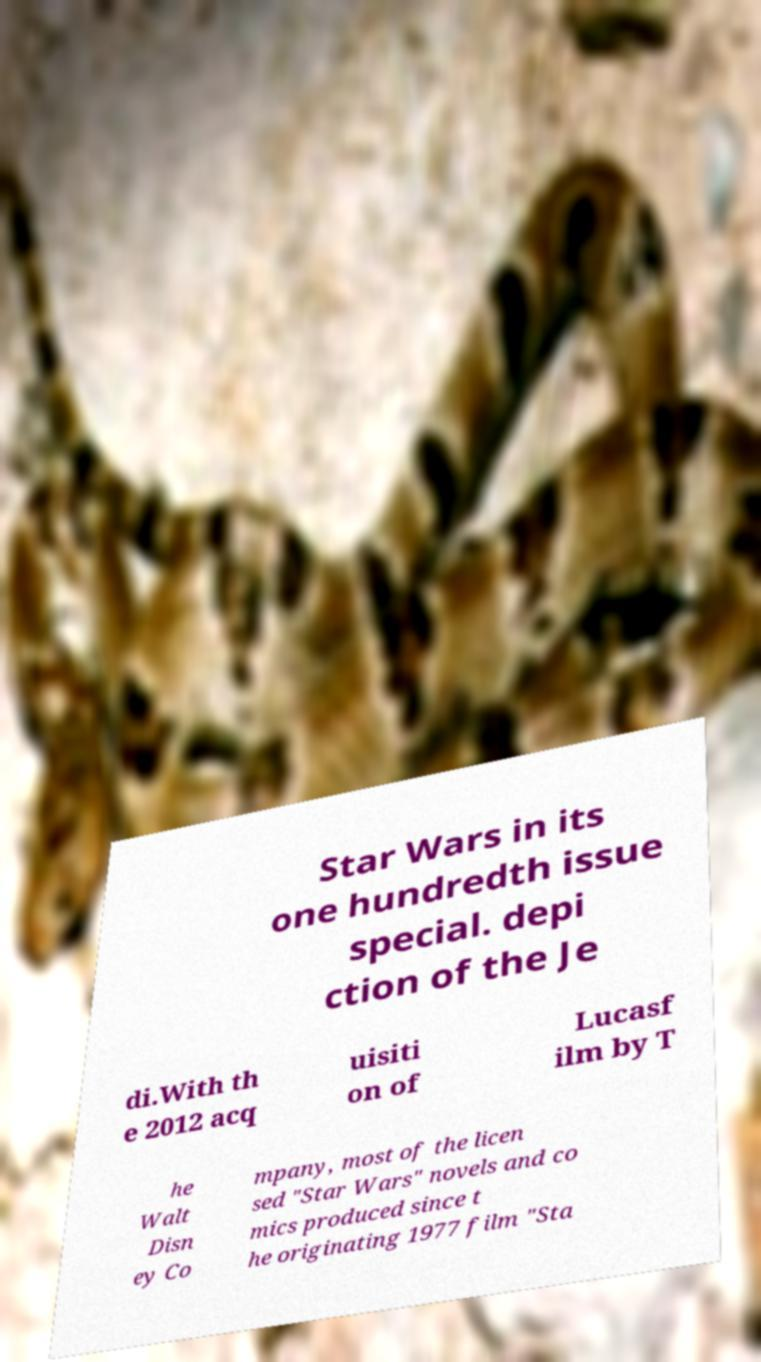Can you read and provide the text displayed in the image?This photo seems to have some interesting text. Can you extract and type it out for me? Star Wars in its one hundredth issue special. depi ction of the Je di.With th e 2012 acq uisiti on of Lucasf ilm by T he Walt Disn ey Co mpany, most of the licen sed "Star Wars" novels and co mics produced since t he originating 1977 film "Sta 